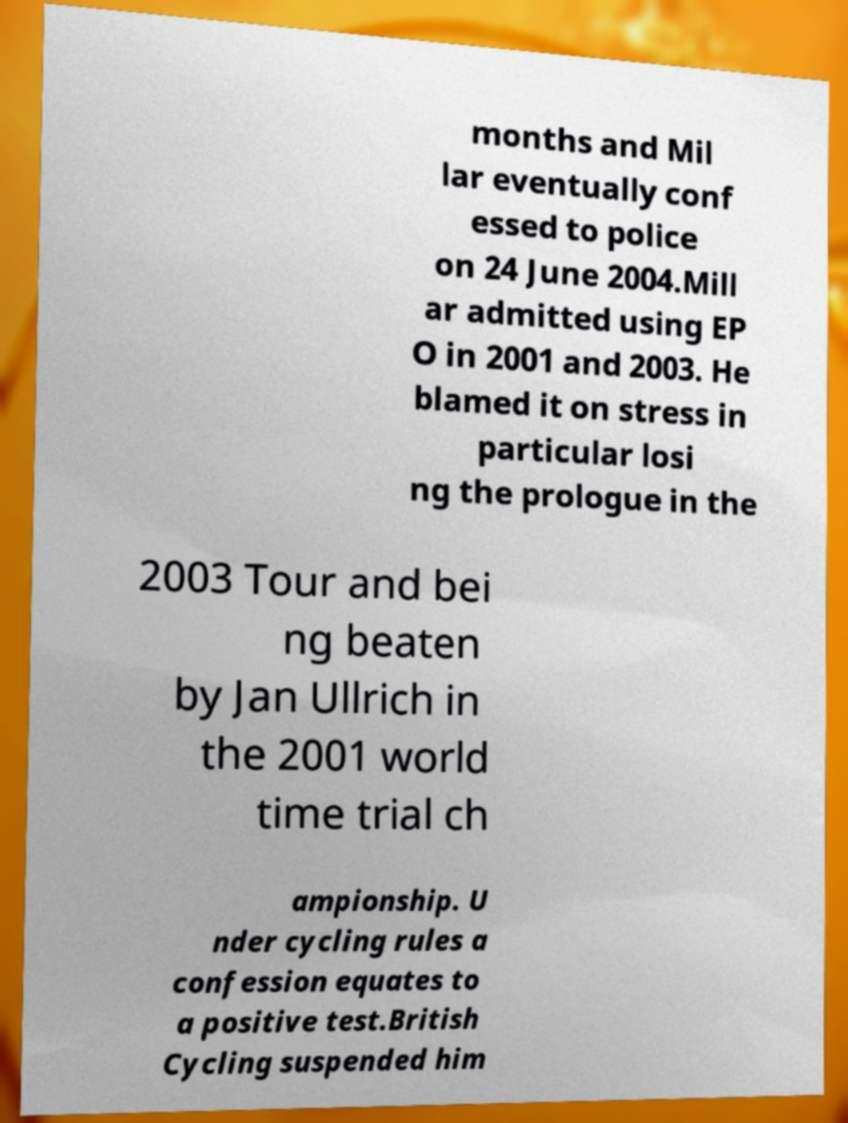Can you read and provide the text displayed in the image?This photo seems to have some interesting text. Can you extract and type it out for me? months and Mil lar eventually conf essed to police on 24 June 2004.Mill ar admitted using EP O in 2001 and 2003. He blamed it on stress in particular losi ng the prologue in the 2003 Tour and bei ng beaten by Jan Ullrich in the 2001 world time trial ch ampionship. U nder cycling rules a confession equates to a positive test.British Cycling suspended him 